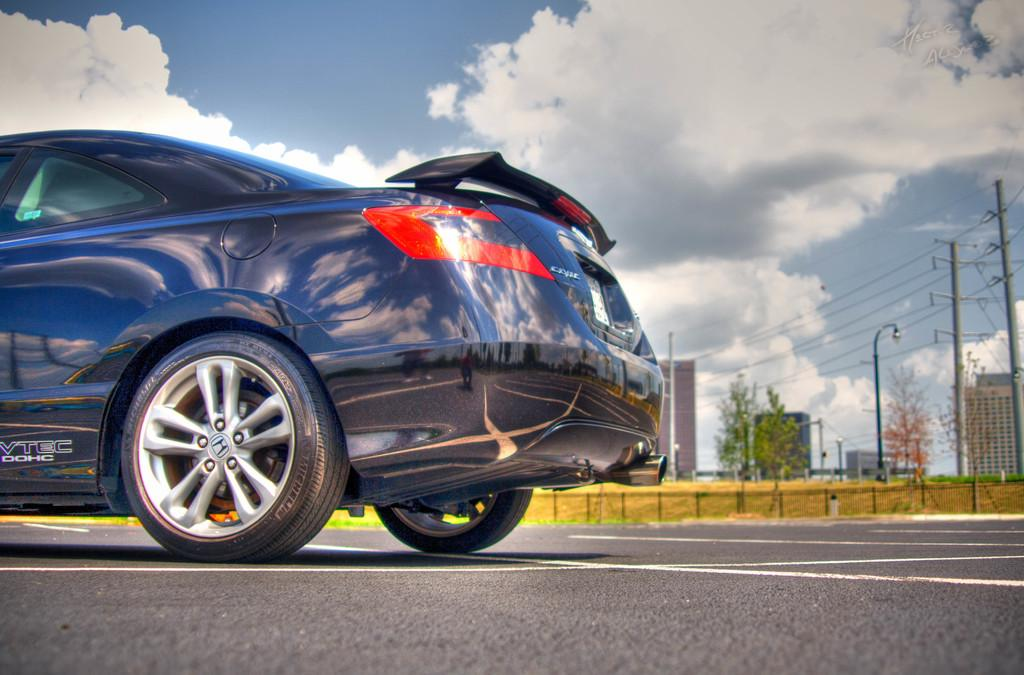What is on the road in the image? There is a vehicle on the road in the image. What type of barrier is present in the image? There is a metal grill fence in the image. What type of natural elements can be seen in the image? Trees are visible in the image. What type of infrastructure is present in the image? Electric poles are present in the image. What is visible in the sky in the image? Clouds are visible in the sky in the image. What type of man-made structures can be seen in the image? There are buildings in the image. What type of juice is being served in the image? There is no juice present in the image; it features a vehicle on the road, a metal grill fence, trees, electric poles, clouds, and buildings. How quiet is the sound in the image? The image does not depict any sound, so it cannot be described as quiet or loud. 